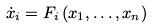Convert formula to latex. <formula><loc_0><loc_0><loc_500><loc_500>\dot { x } _ { i } = F _ { i } \left ( x _ { 1 } , \dots , x _ { n } \right )</formula> 